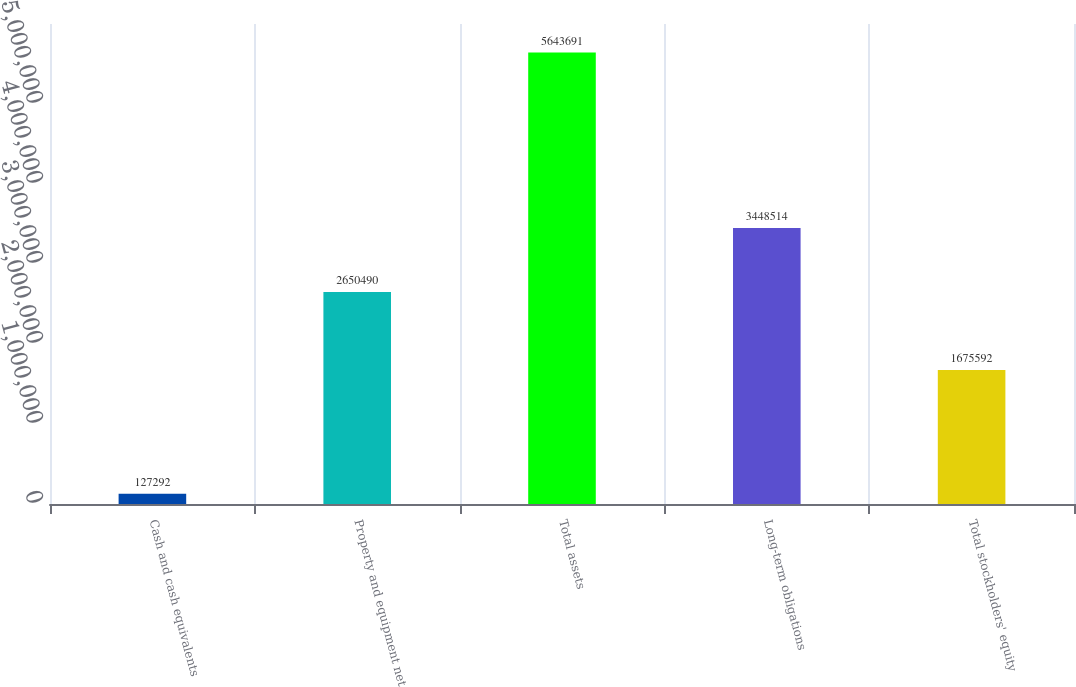Convert chart. <chart><loc_0><loc_0><loc_500><loc_500><bar_chart><fcel>Cash and cash equivalents<fcel>Property and equipment net<fcel>Total assets<fcel>Long-term obligations<fcel>Total stockholders' equity<nl><fcel>127292<fcel>2.65049e+06<fcel>5.64369e+06<fcel>3.44851e+06<fcel>1.67559e+06<nl></chart> 